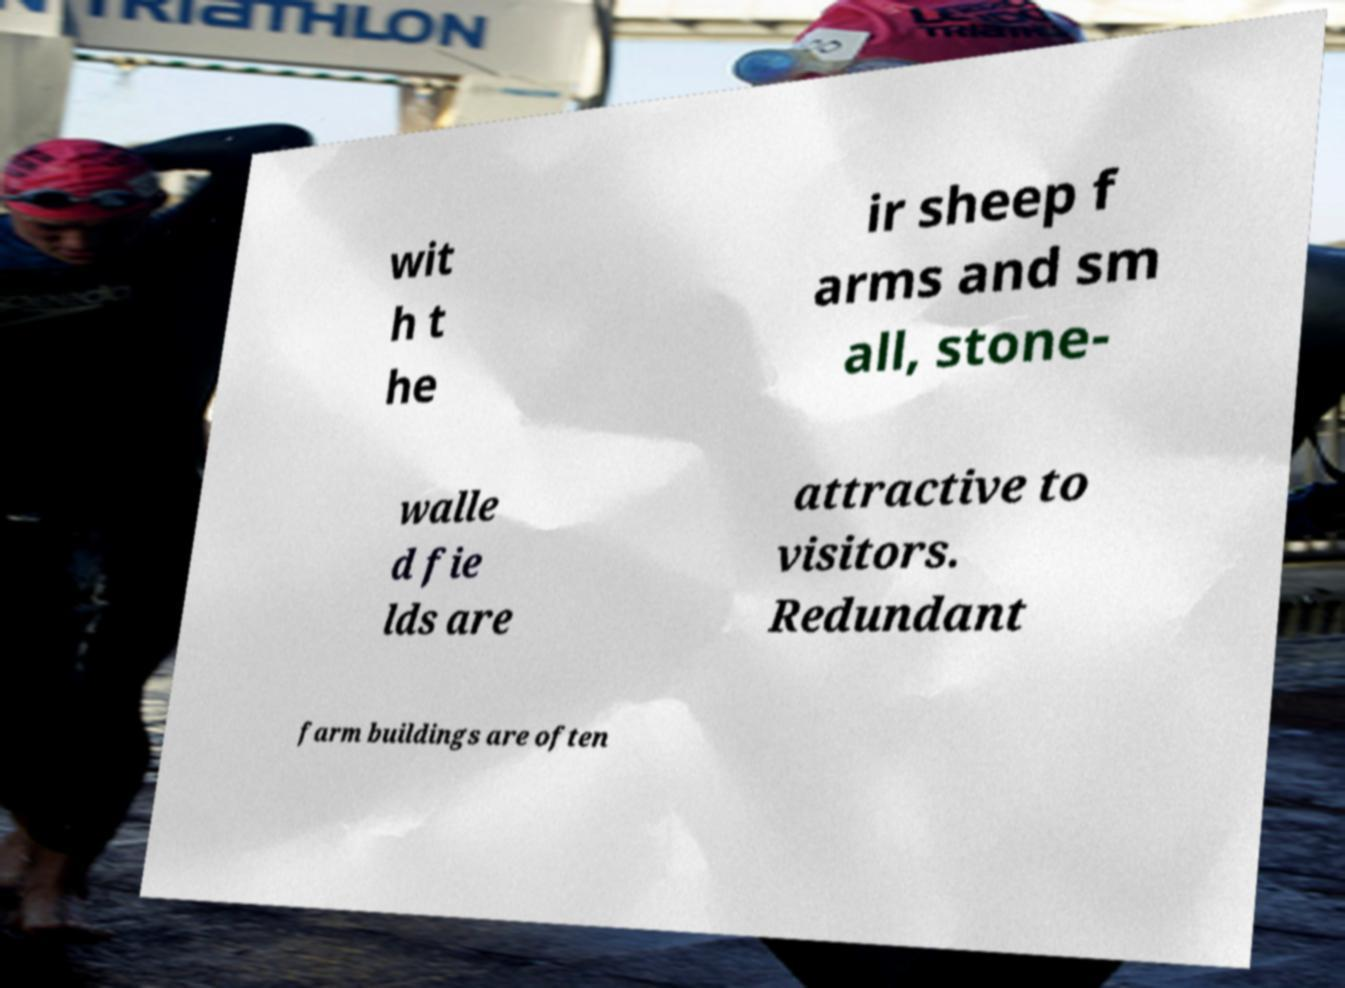There's text embedded in this image that I need extracted. Can you transcribe it verbatim? wit h t he ir sheep f arms and sm all, stone- walle d fie lds are attractive to visitors. Redundant farm buildings are often 